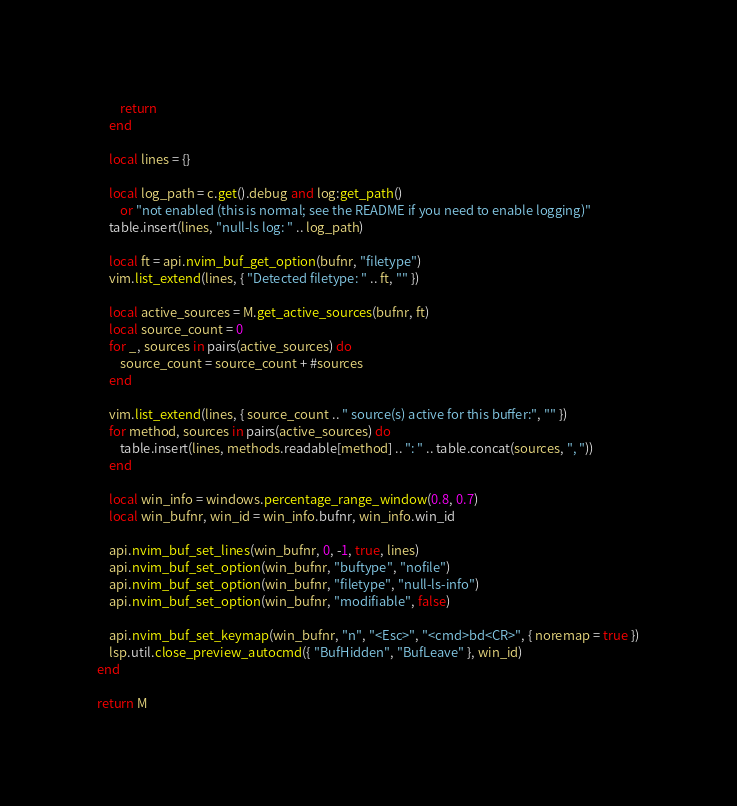Convert code to text. <code><loc_0><loc_0><loc_500><loc_500><_Lua_>        return
    end

    local lines = {}

    local log_path = c.get().debug and log:get_path()
        or "not enabled (this is normal; see the README if you need to enable logging)"
    table.insert(lines, "null-ls log: " .. log_path)

    local ft = api.nvim_buf_get_option(bufnr, "filetype")
    vim.list_extend(lines, { "Detected filetype: " .. ft, "" })

    local active_sources = M.get_active_sources(bufnr, ft)
    local source_count = 0
    for _, sources in pairs(active_sources) do
        source_count = source_count + #sources
    end

    vim.list_extend(lines, { source_count .. " source(s) active for this buffer:", "" })
    for method, sources in pairs(active_sources) do
        table.insert(lines, methods.readable[method] .. ": " .. table.concat(sources, ", "))
    end

    local win_info = windows.percentage_range_window(0.8, 0.7)
    local win_bufnr, win_id = win_info.bufnr, win_info.win_id

    api.nvim_buf_set_lines(win_bufnr, 0, -1, true, lines)
    api.nvim_buf_set_option(win_bufnr, "buftype", "nofile")
    api.nvim_buf_set_option(win_bufnr, "filetype", "null-ls-info")
    api.nvim_buf_set_option(win_bufnr, "modifiable", false)

    api.nvim_buf_set_keymap(win_bufnr, "n", "<Esc>", "<cmd>bd<CR>", { noremap = true })
    lsp.util.close_preview_autocmd({ "BufHidden", "BufLeave" }, win_id)
end

return M
</code> 